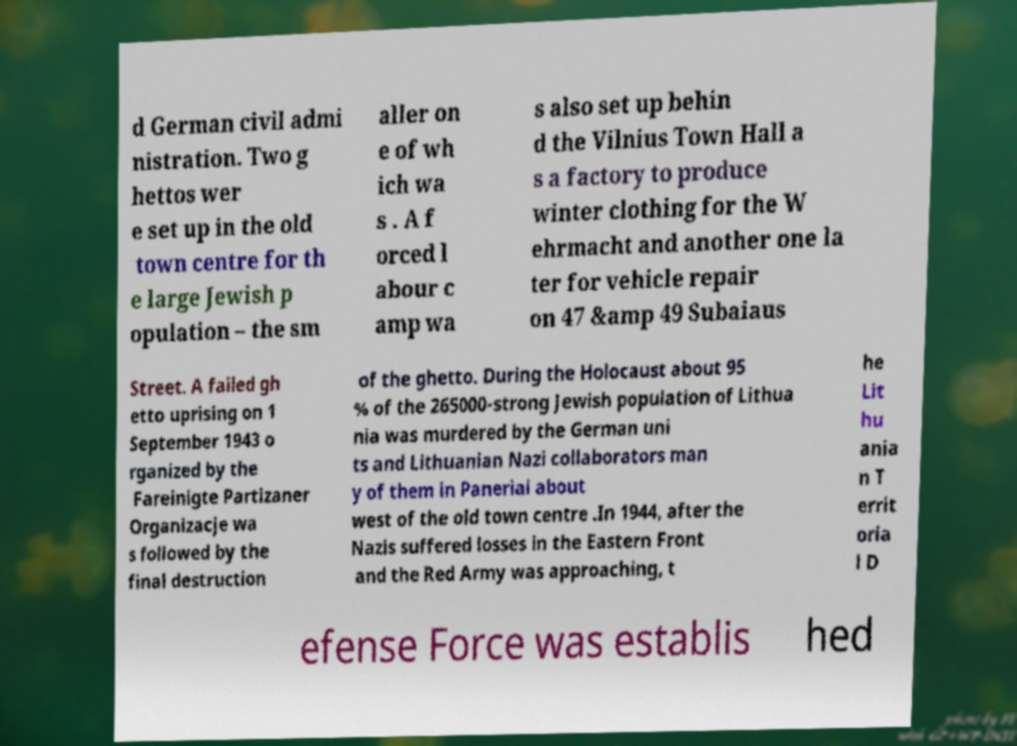Could you extract and type out the text from this image? d German civil admi nistration. Two g hettos wer e set up in the old town centre for th e large Jewish p opulation – the sm aller on e of wh ich wa s . A f orced l abour c amp wa s also set up behin d the Vilnius Town Hall a s a factory to produce winter clothing for the W ehrmacht and another one la ter for vehicle repair on 47 &amp 49 Subaiaus Street. A failed gh etto uprising on 1 September 1943 o rganized by the Fareinigte Partizaner Organizacje wa s followed by the final destruction of the ghetto. During the Holocaust about 95 % of the 265000-strong Jewish population of Lithua nia was murdered by the German uni ts and Lithuanian Nazi collaborators man y of them in Paneriai about west of the old town centre .In 1944, after the Nazis suffered losses in the Eastern Front and the Red Army was approaching, t he Lit hu ania n T errit oria l D efense Force was establis hed 